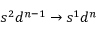Convert formula to latex. <formula><loc_0><loc_0><loc_500><loc_500>s ^ { 2 } d ^ { n - 1 } \to s ^ { 1 } d ^ { n }</formula> 